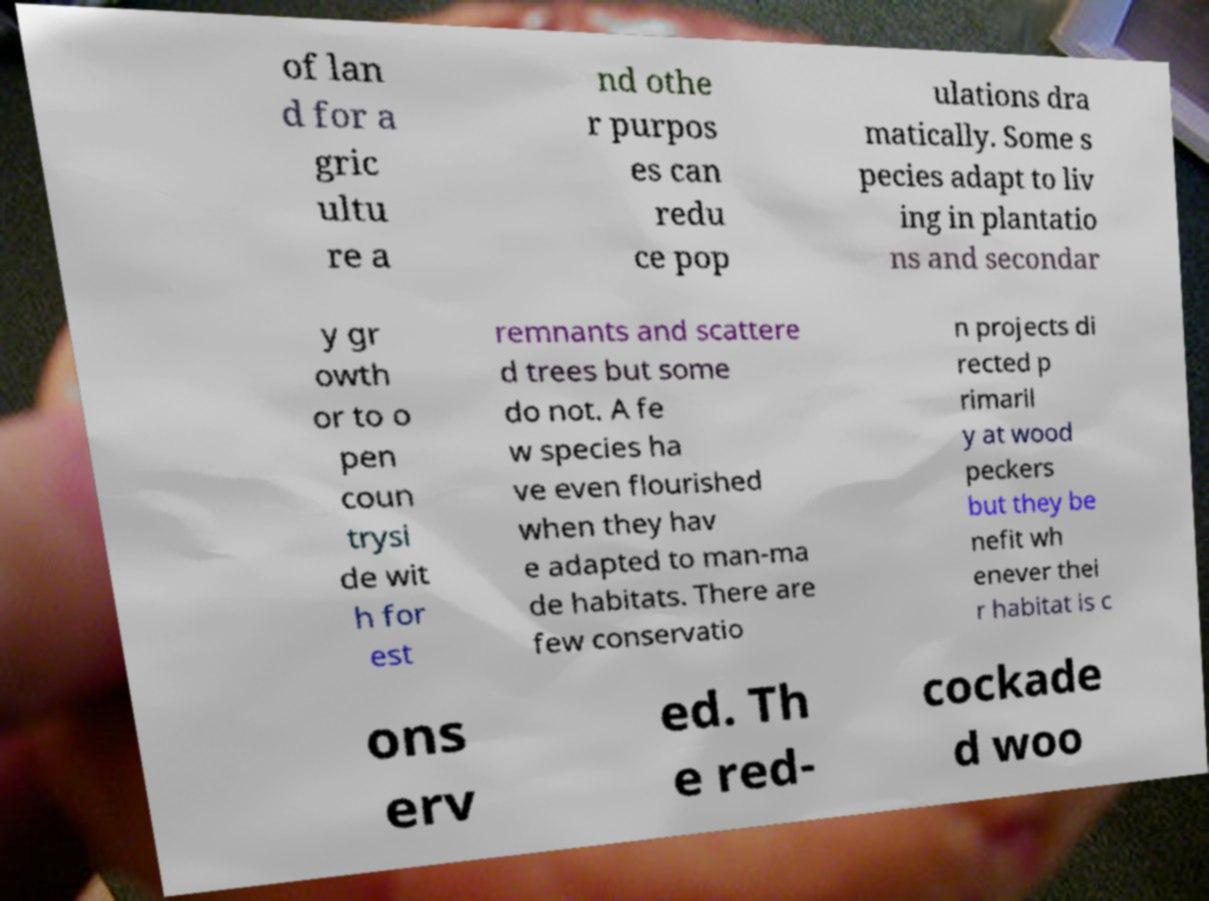Please read and relay the text visible in this image. What does it say? of lan d for a gric ultu re a nd othe r purpos es can redu ce pop ulations dra matically. Some s pecies adapt to liv ing in plantatio ns and secondar y gr owth or to o pen coun trysi de wit h for est remnants and scattere d trees but some do not. A fe w species ha ve even flourished when they hav e adapted to man-ma de habitats. There are few conservatio n projects di rected p rimaril y at wood peckers but they be nefit wh enever thei r habitat is c ons erv ed. Th e red- cockade d woo 